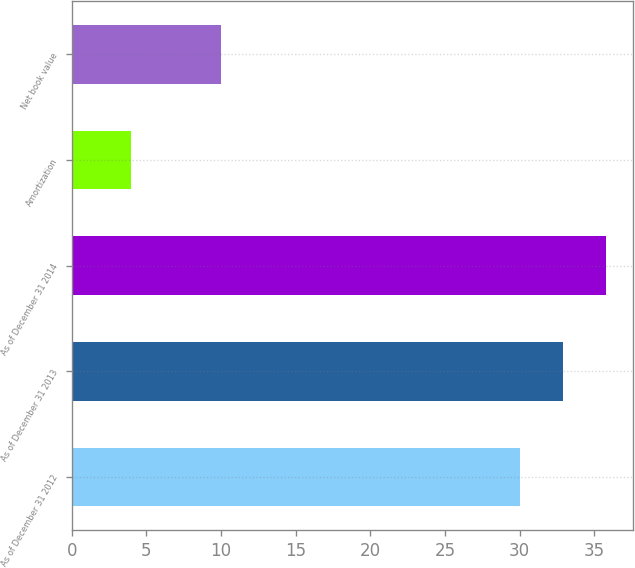<chart> <loc_0><loc_0><loc_500><loc_500><bar_chart><fcel>As of December 31 2012<fcel>As of December 31 2013<fcel>As of December 31 2014<fcel>Amortization<fcel>Net book value<nl><fcel>30<fcel>32.9<fcel>35.8<fcel>4<fcel>10<nl></chart> 